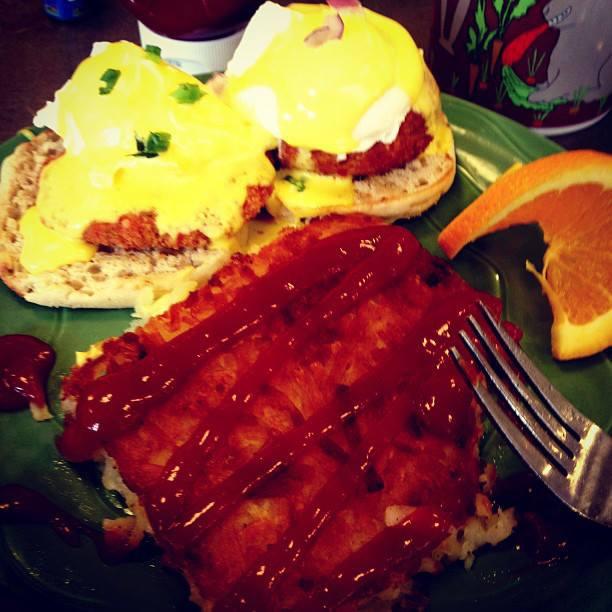If you are allergic to eggs, should you eat this?
Write a very short answer. No. What type of food is in the picture?
Quick response, please. Breakfast. What color is the plate?
Concise answer only. Green. What fruit do you see?
Quick response, please. Orange. What condiment is on the potatoes?
Answer briefly. Ketchup. What is on the plate?
Keep it brief. Food. 